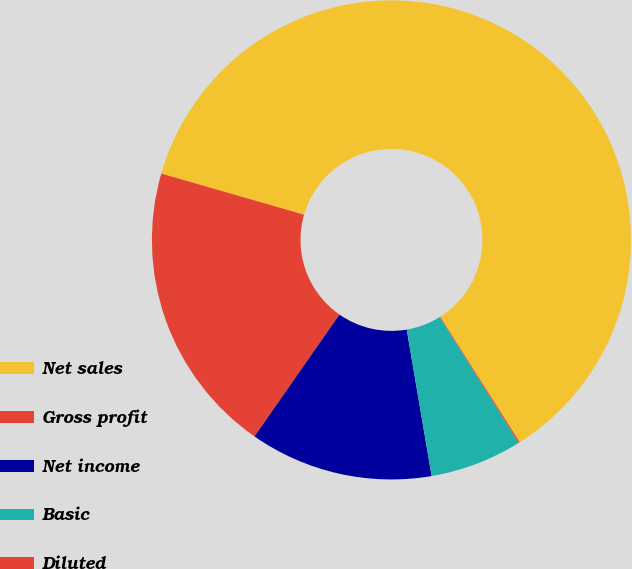Convert chart. <chart><loc_0><loc_0><loc_500><loc_500><pie_chart><fcel>Net sales<fcel>Gross profit<fcel>Net income<fcel>Basic<fcel>Diluted<nl><fcel>61.54%<fcel>19.78%<fcel>12.37%<fcel>6.23%<fcel>0.08%<nl></chart> 